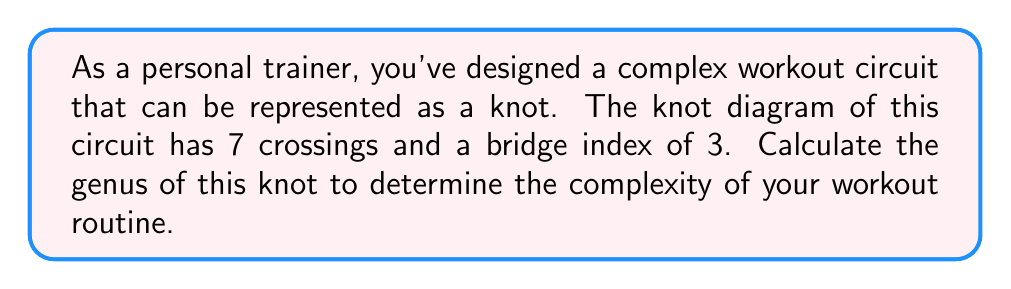What is the answer to this math problem? To find the genus of the knot representing the workout circuit, we'll follow these steps:

1) First, recall the relationship between the genus $g$, the crossing number $c$, and the bridge index $b$ of a knot:

   $$2g \leq c - 2b + 2$$

2) We're given that the crossing number $c = 7$ and the bridge index $b = 3$.

3) Substituting these values into the inequality:

   $$2g \leq 7 - 2(3) + 2$$
   $$2g \leq 7 - 6 + 2$$
   $$2g \leq 3$$

4) Solving for $g$:

   $$g \leq \frac{3}{2}$$

5) Since the genus must be a non-negative integer, the largest possible value for $g$ that satisfies this inequality is 1.

6) Therefore, the genus of the knot is 1.

This genus value indicates that your workout circuit has a moderate level of complexity, as it can be represented by a knot that requires a surface with one hole (like a torus) to embed it without self-intersections.
Answer: $g = 1$ 